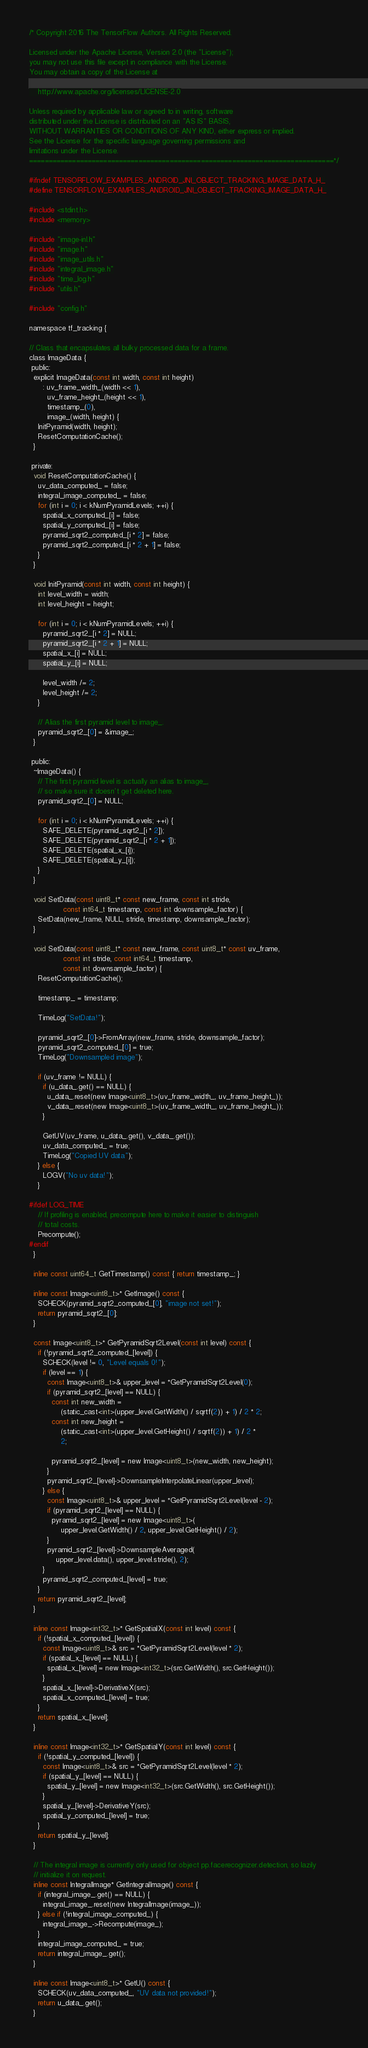<code> <loc_0><loc_0><loc_500><loc_500><_C_>/* Copyright 2016 The TensorFlow Authors. All Rights Reserved.

Licensed under the Apache License, Version 2.0 (the "License");
you may not use this file except in compliance with the License.
You may obtain a copy of the License at

    http://www.apache.org/licenses/LICENSE-2.0

Unless required by applicable law or agreed to in writing, software
distributed under the License is distributed on an "AS IS" BASIS,
WITHOUT WARRANTIES OR CONDITIONS OF ANY KIND, either express or implied.
See the License for the specific language governing permissions and
limitations under the License.
==============================================================================*/

#ifndef TENSORFLOW_EXAMPLES_ANDROID_JNI_OBJECT_TRACKING_IMAGE_DATA_H_
#define TENSORFLOW_EXAMPLES_ANDROID_JNI_OBJECT_TRACKING_IMAGE_DATA_H_

#include <stdint.h>
#include <memory>

#include "image-inl.h"
#include "image.h"
#include "image_utils.h"
#include "integral_image.h"
#include "time_log.h"
#include "utils.h"

#include "config.h"

namespace tf_tracking {

// Class that encapsulates all bulky processed data for a frame.
class ImageData {
 public:
  explicit ImageData(const int width, const int height)
      : uv_frame_width_(width << 1),
        uv_frame_height_(height << 1),
        timestamp_(0),
        image_(width, height) {
    InitPyramid(width, height);
    ResetComputationCache();
  }

 private:
  void ResetComputationCache() {
    uv_data_computed_ = false;
    integral_image_computed_ = false;
    for (int i = 0; i < kNumPyramidLevels; ++i) {
      spatial_x_computed_[i] = false;
      spatial_y_computed_[i] = false;
      pyramid_sqrt2_computed_[i * 2] = false;
      pyramid_sqrt2_computed_[i * 2 + 1] = false;
    }
  }

  void InitPyramid(const int width, const int height) {
    int level_width = width;
    int level_height = height;

    for (int i = 0; i < kNumPyramidLevels; ++i) {
      pyramid_sqrt2_[i * 2] = NULL;
      pyramid_sqrt2_[i * 2 + 1] = NULL;
      spatial_x_[i] = NULL;
      spatial_y_[i] = NULL;

      level_width /= 2;
      level_height /= 2;
    }

    // Alias the first pyramid level to image_.
    pyramid_sqrt2_[0] = &image_;
  }

 public:
  ~ImageData() {
    // The first pyramid level is actually an alias to image_,
    // so make sure it doesn't get deleted here.
    pyramid_sqrt2_[0] = NULL;

    for (int i = 0; i < kNumPyramidLevels; ++i) {
      SAFE_DELETE(pyramid_sqrt2_[i * 2]);
      SAFE_DELETE(pyramid_sqrt2_[i * 2 + 1]);
      SAFE_DELETE(spatial_x_[i]);
      SAFE_DELETE(spatial_y_[i]);
    }
  }

  void SetData(const uint8_t* const new_frame, const int stride,
               const int64_t timestamp, const int downsample_factor) {
    SetData(new_frame, NULL, stride, timestamp, downsample_factor);
  }

  void SetData(const uint8_t* const new_frame, const uint8_t* const uv_frame,
               const int stride, const int64_t timestamp,
               const int downsample_factor) {
    ResetComputationCache();

    timestamp_ = timestamp;

    TimeLog("SetData!");

    pyramid_sqrt2_[0]->FromArray(new_frame, stride, downsample_factor);
    pyramid_sqrt2_computed_[0] = true;
    TimeLog("Downsampled image");

    if (uv_frame != NULL) {
      if (u_data_.get() == NULL) {
        u_data_.reset(new Image<uint8_t>(uv_frame_width_, uv_frame_height_));
        v_data_.reset(new Image<uint8_t>(uv_frame_width_, uv_frame_height_));
      }

      GetUV(uv_frame, u_data_.get(), v_data_.get());
      uv_data_computed_ = true;
      TimeLog("Copied UV data");
    } else {
      LOGV("No uv data!");
    }

#ifdef LOG_TIME
    // If profiling is enabled, precompute here to make it easier to distinguish
    // total costs.
    Precompute();
#endif
  }

  inline const uint64_t GetTimestamp() const { return timestamp_; }

  inline const Image<uint8_t>* GetImage() const {
    SCHECK(pyramid_sqrt2_computed_[0], "image not set!");
    return pyramid_sqrt2_[0];
  }

  const Image<uint8_t>* GetPyramidSqrt2Level(const int level) const {
    if (!pyramid_sqrt2_computed_[level]) {
      SCHECK(level != 0, "Level equals 0!");
      if (level == 1) {
        const Image<uint8_t>& upper_level = *GetPyramidSqrt2Level(0);
        if (pyramid_sqrt2_[level] == NULL) {
          const int new_width =
              (static_cast<int>(upper_level.GetWidth() / sqrtf(2)) + 1) / 2 * 2;
          const int new_height =
              (static_cast<int>(upper_level.GetHeight() / sqrtf(2)) + 1) / 2 *
              2;

          pyramid_sqrt2_[level] = new Image<uint8_t>(new_width, new_height);
        }
        pyramid_sqrt2_[level]->DownsampleInterpolateLinear(upper_level);
      } else {
        const Image<uint8_t>& upper_level = *GetPyramidSqrt2Level(level - 2);
        if (pyramid_sqrt2_[level] == NULL) {
          pyramid_sqrt2_[level] = new Image<uint8_t>(
              upper_level.GetWidth() / 2, upper_level.GetHeight() / 2);
        }
        pyramid_sqrt2_[level]->DownsampleAveraged(
            upper_level.data(), upper_level.stride(), 2);
      }
      pyramid_sqrt2_computed_[level] = true;
    }
    return pyramid_sqrt2_[level];
  }

  inline const Image<int32_t>* GetSpatialX(const int level) const {
    if (!spatial_x_computed_[level]) {
      const Image<uint8_t>& src = *GetPyramidSqrt2Level(level * 2);
      if (spatial_x_[level] == NULL) {
        spatial_x_[level] = new Image<int32_t>(src.GetWidth(), src.GetHeight());
      }
      spatial_x_[level]->DerivativeX(src);
      spatial_x_computed_[level] = true;
    }
    return spatial_x_[level];
  }

  inline const Image<int32_t>* GetSpatialY(const int level) const {
    if (!spatial_y_computed_[level]) {
      const Image<uint8_t>& src = *GetPyramidSqrt2Level(level * 2);
      if (spatial_y_[level] == NULL) {
        spatial_y_[level] = new Image<int32_t>(src.GetWidth(), src.GetHeight());
      }
      spatial_y_[level]->DerivativeY(src);
      spatial_y_computed_[level] = true;
    }
    return spatial_y_[level];
  }

  // The integral image is currently only used for object pp.facerecognizer.detection, so lazily
  // initialize it on request.
  inline const IntegralImage* GetIntegralImage() const {
    if (integral_image_.get() == NULL) {
      integral_image_.reset(new IntegralImage(image_));
    } else if (!integral_image_computed_) {
      integral_image_->Recompute(image_);
    }
    integral_image_computed_ = true;
    return integral_image_.get();
  }

  inline const Image<uint8_t>* GetU() const {
    SCHECK(uv_data_computed_, "UV data not provided!");
    return u_data_.get();
  }
</code> 